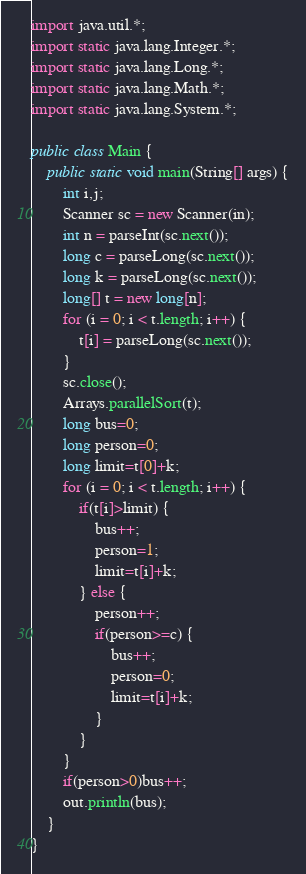Convert code to text. <code><loc_0><loc_0><loc_500><loc_500><_Java_>import java.util.*;
import static java.lang.Integer.*;
import static java.lang.Long.*;
import static java.lang.Math.*;
import static java.lang.System.*;

public class Main {
	public static void main(String[] args) {
		int i,j;
		Scanner sc = new Scanner(in);
		int n = parseInt(sc.next());
		long c = parseLong(sc.next());
		long k = parseLong(sc.next());
		long[] t = new long[n];
		for (i = 0; i < t.length; i++) {
			t[i] = parseLong(sc.next());
		}
		sc.close();
		Arrays.parallelSort(t);
		long bus=0;
		long person=0;
		long limit=t[0]+k;
		for (i = 0; i < t.length; i++) {
			if(t[i]>limit) {
				bus++;
				person=1;
				limit=t[i]+k;
			} else {
				person++;
				if(person>=c) {
					bus++;
					person=0;
					limit=t[i]+k;
				}
			}
		}
		if(person>0)bus++;
		out.println(bus);
	}
}
</code> 